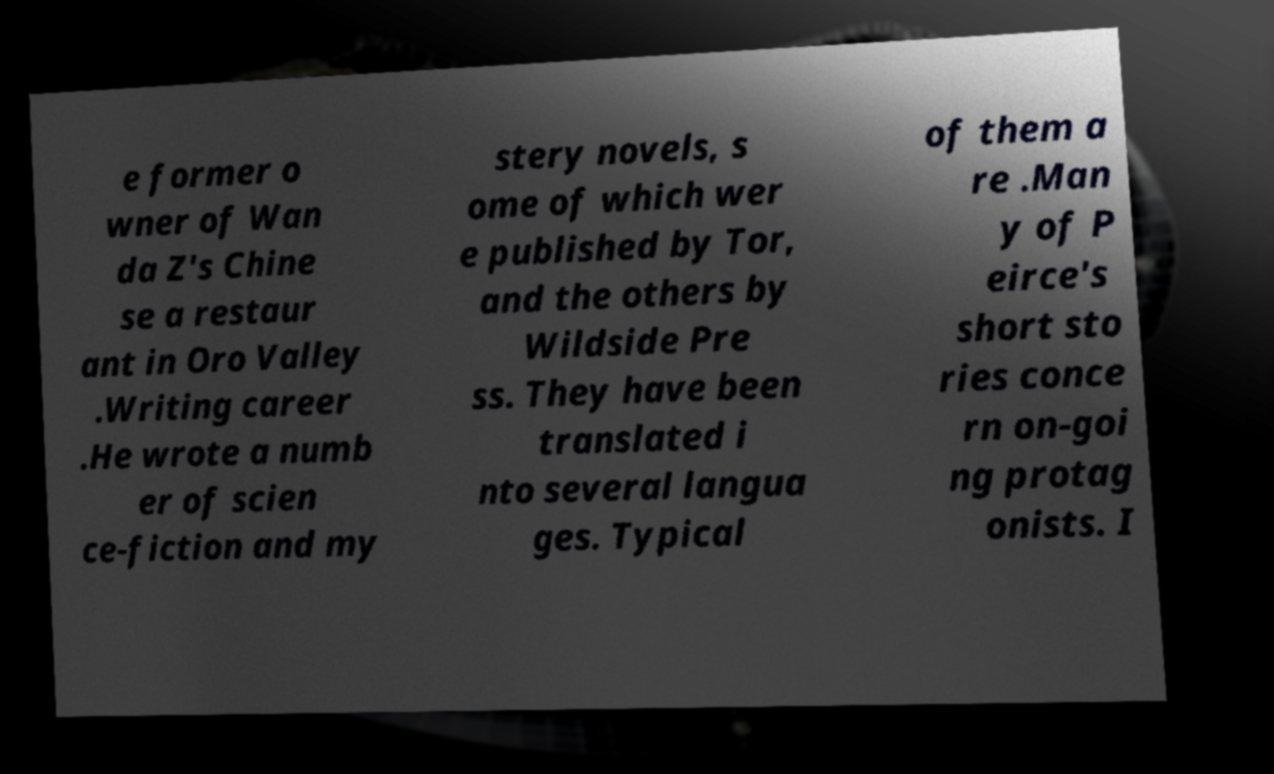What messages or text are displayed in this image? I need them in a readable, typed format. e former o wner of Wan da Z's Chine se a restaur ant in Oro Valley .Writing career .He wrote a numb er of scien ce-fiction and my stery novels, s ome of which wer e published by Tor, and the others by Wildside Pre ss. They have been translated i nto several langua ges. Typical of them a re .Man y of P eirce's short sto ries conce rn on-goi ng protag onists. I 